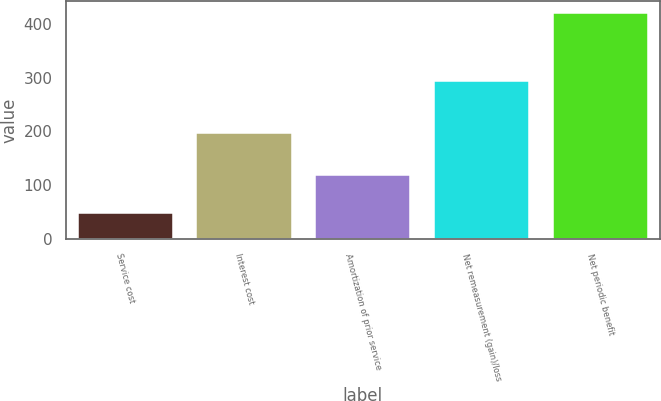Convert chart to OTSL. <chart><loc_0><loc_0><loc_500><loc_500><bar_chart><fcel>Service cost<fcel>Interest cost<fcel>Amortization of prior service<fcel>Net remeasurement (gain)/loss<fcel>Net periodic benefit<nl><fcel>49<fcel>197<fcel>120<fcel>293<fcel>421<nl></chart> 